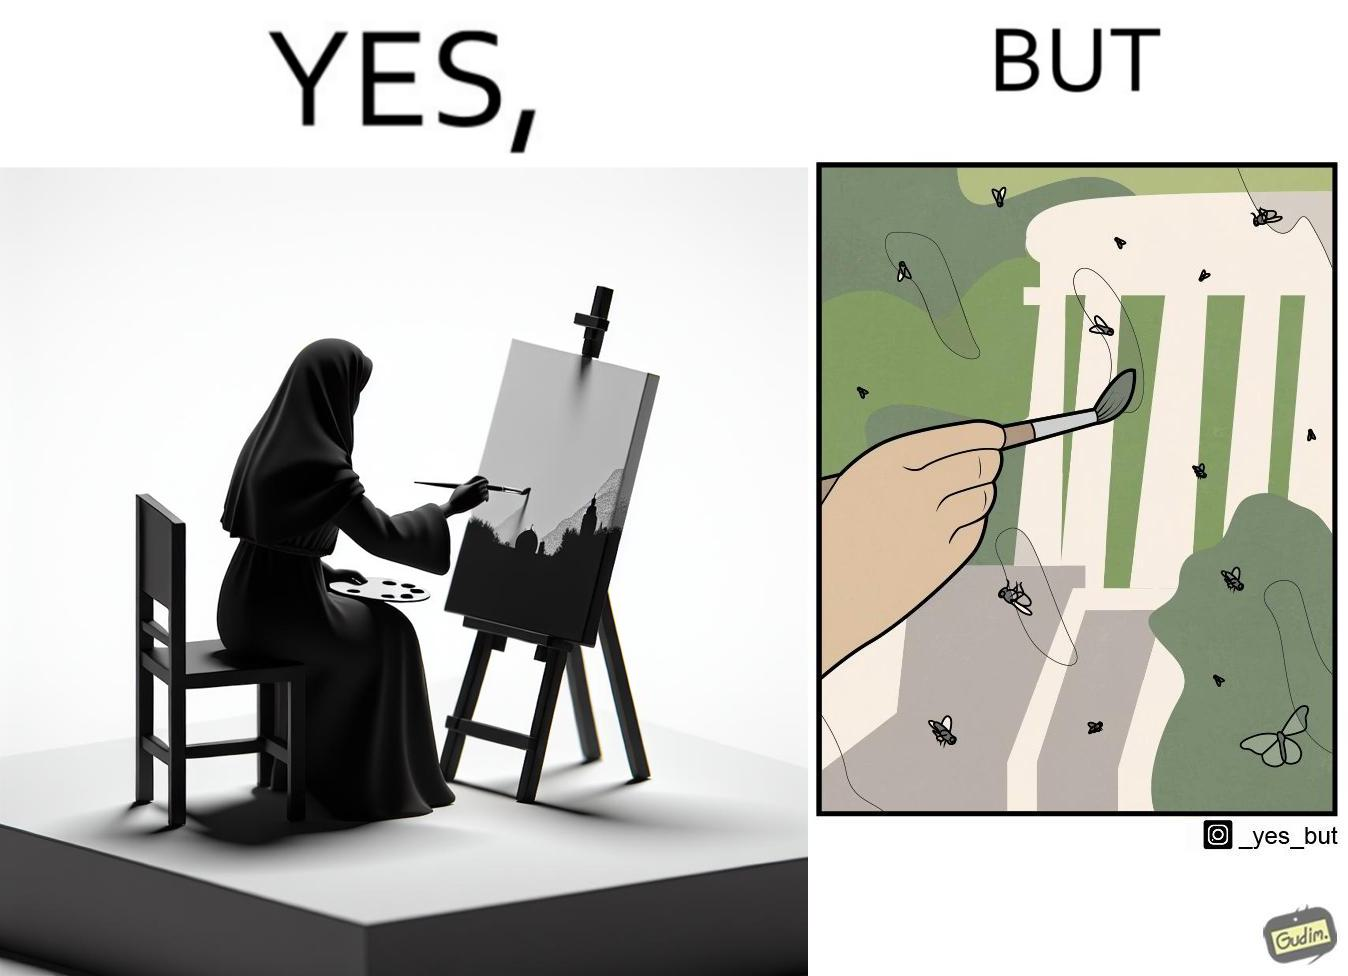Would you classify this image as satirical? Yes, this image is satirical. 